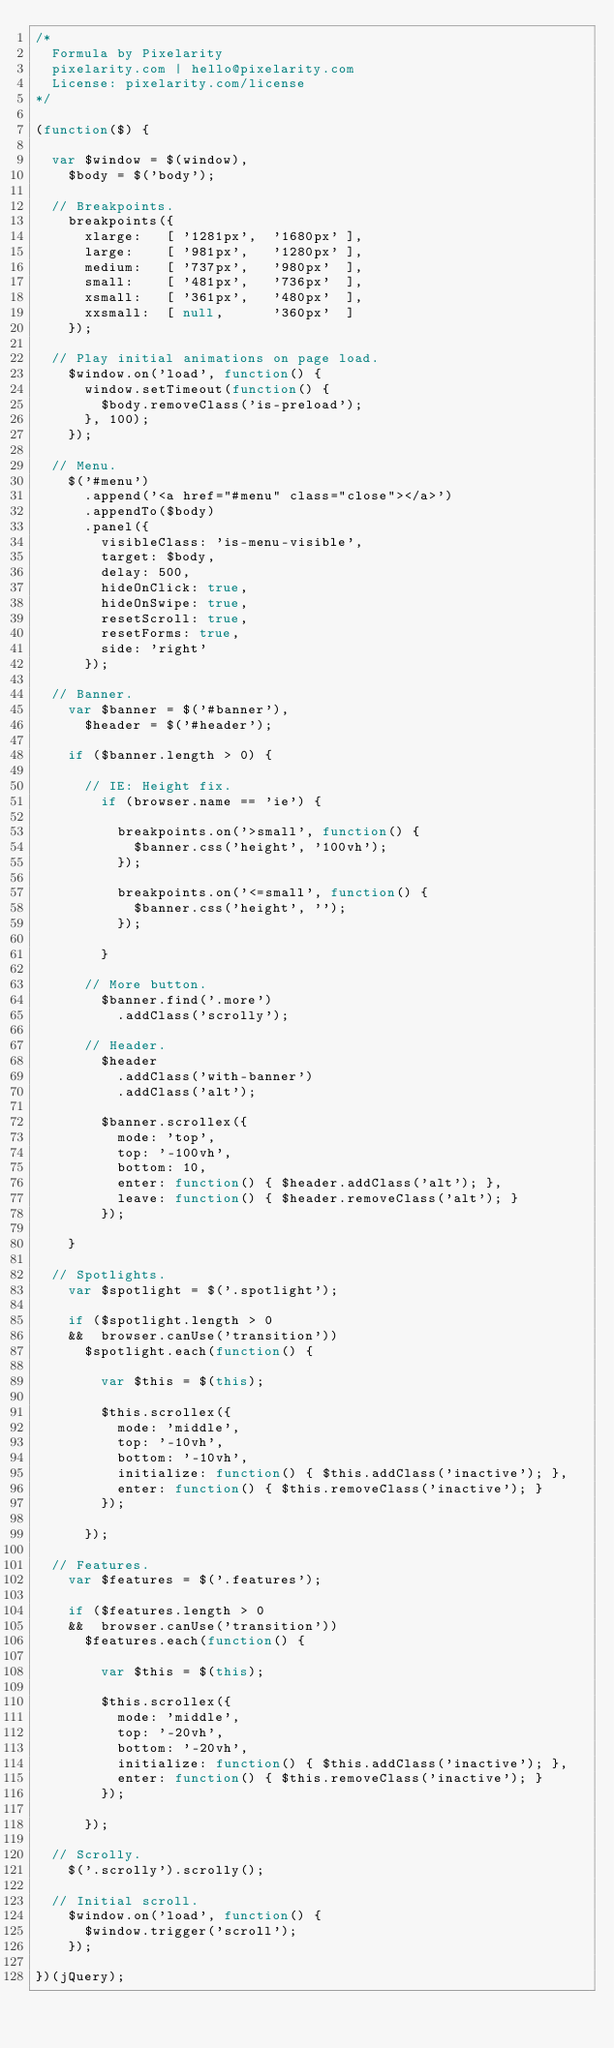Convert code to text. <code><loc_0><loc_0><loc_500><loc_500><_JavaScript_>/*
	Formula by Pixelarity
	pixelarity.com | hello@pixelarity.com
	License: pixelarity.com/license
*/

(function($) {

	var	$window = $(window),
		$body = $('body');

	// Breakpoints.
		breakpoints({
			xlarge:   [ '1281px',  '1680px' ],
			large:    [ '981px',   '1280px' ],
			medium:   [ '737px',   '980px'  ],
			small:    [ '481px',   '736px'  ],
			xsmall:   [ '361px',   '480px'  ],
			xxsmall:  [ null,      '360px'  ]
		});

	// Play initial animations on page load.
		$window.on('load', function() {
			window.setTimeout(function() {
				$body.removeClass('is-preload');
			}, 100);
		});

	// Menu.
		$('#menu')
			.append('<a href="#menu" class="close"></a>')
			.appendTo($body)
			.panel({
				visibleClass: 'is-menu-visible',
				target: $body,
				delay: 500,
				hideOnClick: true,
				hideOnSwipe: true,
				resetScroll: true,
				resetForms: true,
				side: 'right'
			});

	// Banner.
		var $banner = $('#banner'),
			$header = $('#header');

		if ($banner.length > 0) {

			// IE: Height fix.
				if (browser.name == 'ie') {

					breakpoints.on('>small', function() {
						$banner.css('height', '100vh');
					});

					breakpoints.on('<=small', function() {
						$banner.css('height', '');
					});

				}

			// More button.
				$banner.find('.more')
					.addClass('scrolly');

			// Header.
				$header
					.addClass('with-banner')
					.addClass('alt');

				$banner.scrollex({
					mode: 'top',
					top: '-100vh',
					bottom: 10,
					enter: function() { $header.addClass('alt'); },
					leave: function() { $header.removeClass('alt'); }
				});

		}

	// Spotlights.
		var $spotlight = $('.spotlight');

		if ($spotlight.length > 0
		&&	browser.canUse('transition'))
			$spotlight.each(function() {

				var $this = $(this);

				$this.scrollex({
					mode: 'middle',
					top: '-10vh',
					bottom: '-10vh',
					initialize: function() { $this.addClass('inactive'); },
					enter: function() { $this.removeClass('inactive'); }
				});

			});

	// Features.
		var $features = $('.features');

		if ($features.length > 0
		&&	browser.canUse('transition'))
			$features.each(function() {

				var $this = $(this);

				$this.scrollex({
					mode: 'middle',
					top: '-20vh',
					bottom: '-20vh',
					initialize: function() { $this.addClass('inactive'); },
					enter: function() { $this.removeClass('inactive'); }
				});

			});

	// Scrolly.
		$('.scrolly').scrolly();

	// Initial scroll.
		$window.on('load', function() {
			$window.trigger('scroll');
		});

})(jQuery);</code> 